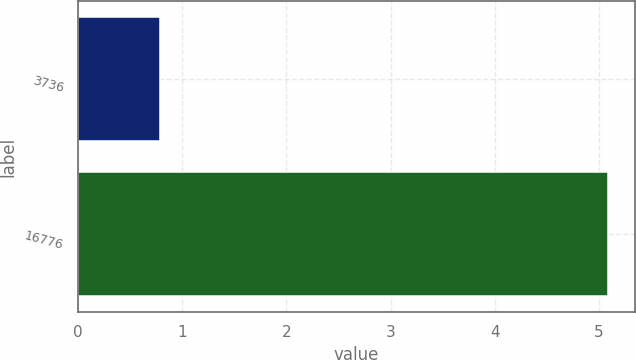Convert chart to OTSL. <chart><loc_0><loc_0><loc_500><loc_500><bar_chart><fcel>3736<fcel>16776<nl><fcel>0.79<fcel>5.09<nl></chart> 